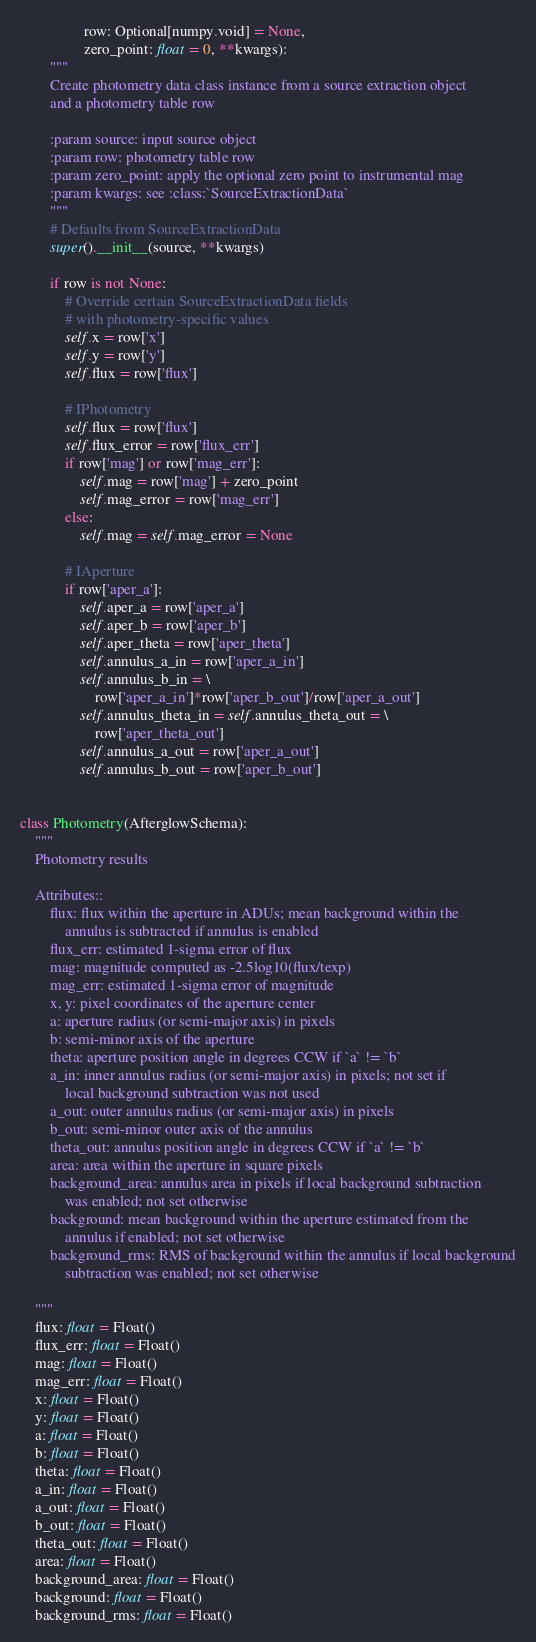<code> <loc_0><loc_0><loc_500><loc_500><_Python_>                 row: Optional[numpy.void] = None,
                 zero_point: float = 0, **kwargs):
        """
        Create photometry data class instance from a source extraction object
        and a photometry table row

        :param source: input source object
        :param row: photometry table row
        :param zero_point: apply the optional zero point to instrumental mag
        :param kwargs: see :class:`SourceExtractionData`
        """
        # Defaults from SourceExtractionData
        super().__init__(source, **kwargs)

        if row is not None:
            # Override certain SourceExtractionData fields
            # with photometry-specific values
            self.x = row['x']
            self.y = row['y']
            self.flux = row['flux']

            # IPhotometry
            self.flux = row['flux']
            self.flux_error = row['flux_err']
            if row['mag'] or row['mag_err']:
                self.mag = row['mag'] + zero_point
                self.mag_error = row['mag_err']
            else:
                self.mag = self.mag_error = None

            # IAperture
            if row['aper_a']:
                self.aper_a = row['aper_a']
                self.aper_b = row['aper_b']
                self.aper_theta = row['aper_theta']
                self.annulus_a_in = row['aper_a_in']
                self.annulus_b_in = \
                    row['aper_a_in']*row['aper_b_out']/row['aper_a_out']
                self.annulus_theta_in = self.annulus_theta_out = \
                    row['aper_theta_out']
                self.annulus_a_out = row['aper_a_out']
                self.annulus_b_out = row['aper_b_out']


class Photometry(AfterglowSchema):
    """
    Photometry results

    Attributes::
        flux: flux within the aperture in ADUs; mean background within the
            annulus is subtracted if annulus is enabled
        flux_err: estimated 1-sigma error of flux
        mag: magnitude computed as -2.5log10(flux/texp)
        mag_err: estimated 1-sigma error of magnitude
        x, y: pixel coordinates of the aperture center
        a: aperture radius (or semi-major axis) in pixels
        b: semi-minor axis of the aperture
        theta: aperture position angle in degrees CCW if `a` != `b`
        a_in: inner annulus radius (or semi-major axis) in pixels; not set if
            local background subtraction was not used
        a_out: outer annulus radius (or semi-major axis) in pixels
        b_out: semi-minor outer axis of the annulus
        theta_out: annulus position angle in degrees CCW if `a` != `b`
        area: area within the aperture in square pixels
        background_area: annulus area in pixels if local background subtraction
            was enabled; not set otherwise
        background: mean background within the aperture estimated from the
            annulus if enabled; not set otherwise
        background_rms: RMS of background within the annulus if local background
            subtraction was enabled; not set otherwise

    """
    flux: float = Float()
    flux_err: float = Float()
    mag: float = Float()
    mag_err: float = Float()
    x: float = Float()
    y: float = Float()
    a: float = Float()
    b: float = Float()
    theta: float = Float()
    a_in: float = Float()
    a_out: float = Float()
    b_out: float = Float()
    theta_out: float = Float()
    area: float = Float()
    background_area: float = Float()
    background: float = Float()
    background_rms: float = Float()
</code> 